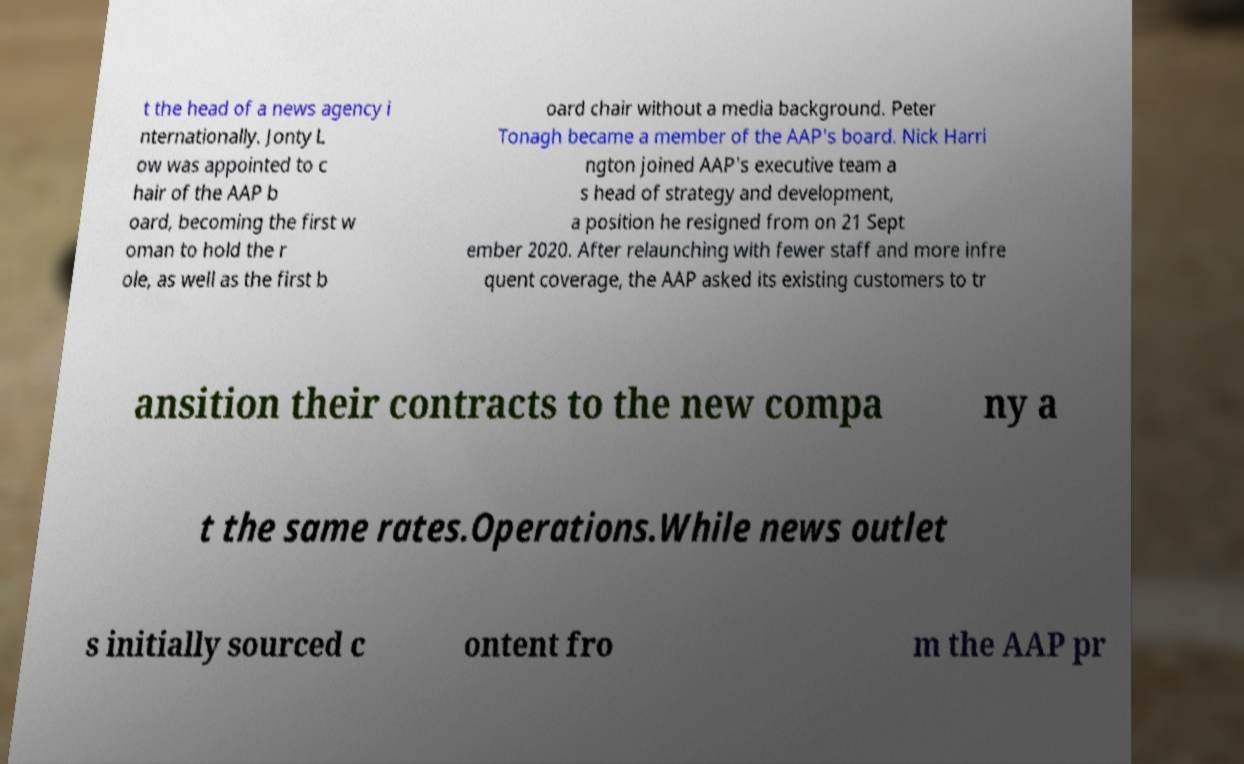Can you read and provide the text displayed in the image?This photo seems to have some interesting text. Can you extract and type it out for me? t the head of a news agency i nternationally. Jonty L ow was appointed to c hair of the AAP b oard, becoming the first w oman to hold the r ole, as well as the first b oard chair without a media background. Peter Tonagh became a member of the AAP's board. Nick Harri ngton joined AAP's executive team a s head of strategy and development, a position he resigned from on 21 Sept ember 2020. After relaunching with fewer staff and more infre quent coverage, the AAP asked its existing customers to tr ansition their contracts to the new compa ny a t the same rates.Operations.While news outlet s initially sourced c ontent fro m the AAP pr 